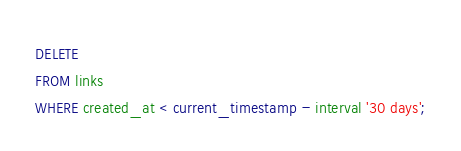<code> <loc_0><loc_0><loc_500><loc_500><_SQL_>DELETE 
FROM links 
WHERE created_at < current_timestamp - interval '30 days';
</code> 